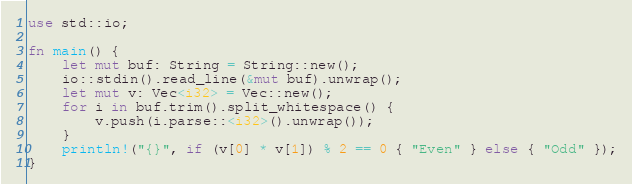Convert code to text. <code><loc_0><loc_0><loc_500><loc_500><_Rust_>use std::io;

fn main() {
    let mut buf: String = String::new();
    io::stdin().read_line(&mut buf).unwrap();
    let mut v: Vec<i32> = Vec::new();
    for i in buf.trim().split_whitespace() {
        v.push(i.parse::<i32>().unwrap());
    }
    println!("{}", if (v[0] * v[1]) % 2 == 0 { "Even" } else { "Odd" });
}
</code> 